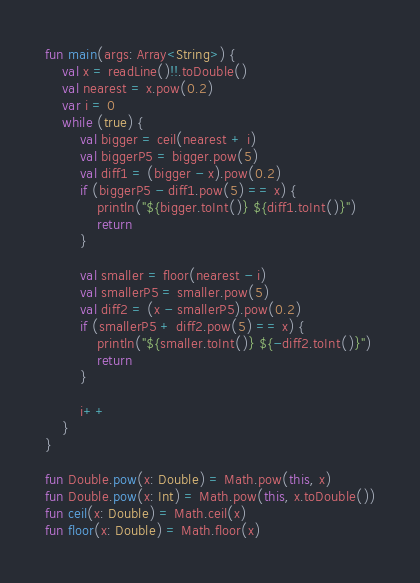Convert code to text. <code><loc_0><loc_0><loc_500><loc_500><_Kotlin_>
fun main(args: Array<String>) {
    val x = readLine()!!.toDouble()
    val nearest = x.pow(0.2)
    var i = 0
    while (true) {
        val bigger = ceil(nearest + i)
        val biggerP5 = bigger.pow(5)
        val diff1 = (bigger - x).pow(0.2)
        if (biggerP5 - diff1.pow(5) == x) {
            println("${bigger.toInt()} ${diff1.toInt()}")
            return
        }

        val smaller = floor(nearest - i)
        val smallerP5 = smaller.pow(5)
        val diff2 = (x - smallerP5).pow(0.2)
        if (smallerP5 + diff2.pow(5) == x) {
            println("${smaller.toInt()} ${-diff2.toInt()}")
            return
        }

        i++
    }
}

fun Double.pow(x: Double) = Math.pow(this, x)
fun Double.pow(x: Int) = Math.pow(this, x.toDouble())
fun ceil(x: Double) = Math.ceil(x)
fun floor(x: Double) = Math.floor(x)</code> 